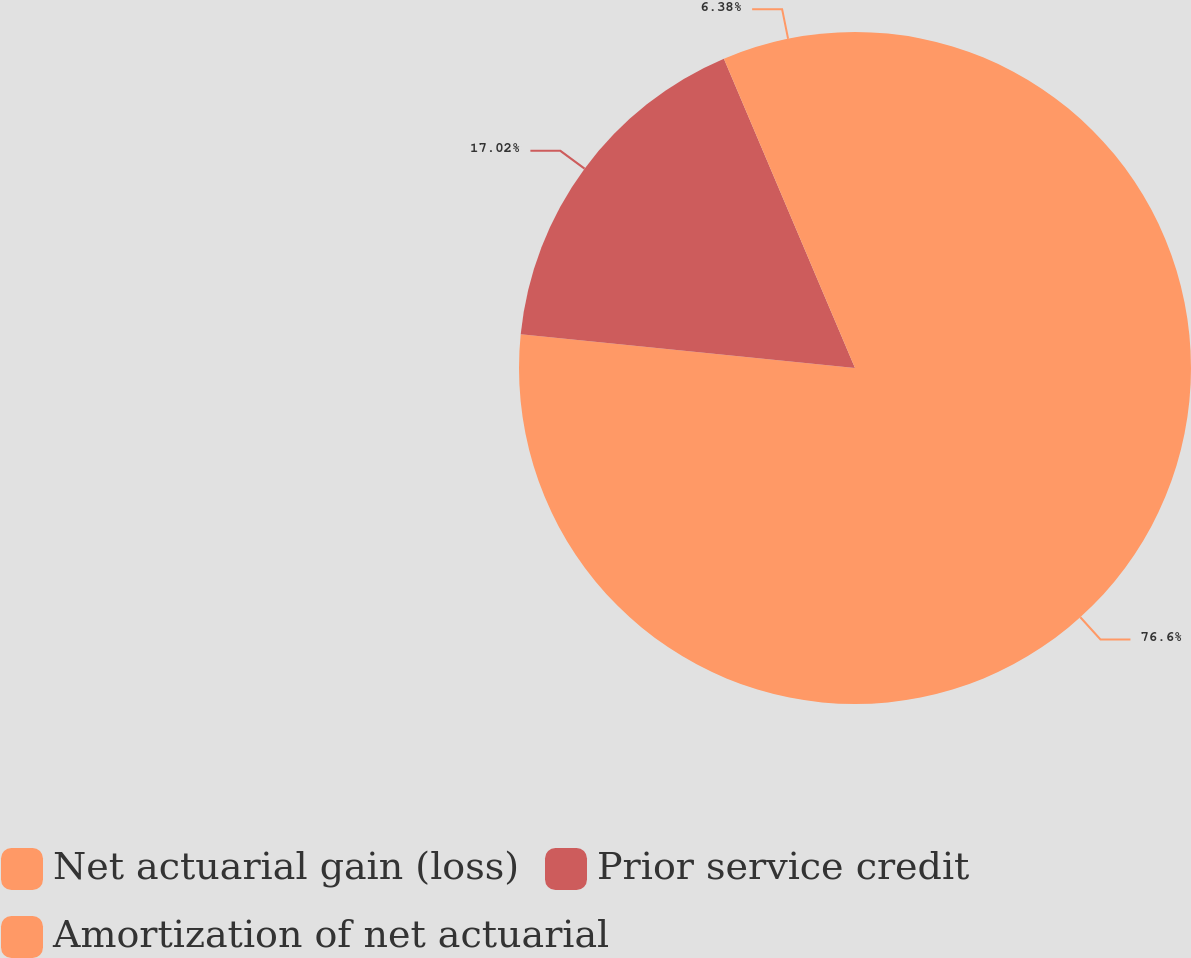<chart> <loc_0><loc_0><loc_500><loc_500><pie_chart><fcel>Net actuarial gain (loss)<fcel>Prior service credit<fcel>Amortization of net actuarial<nl><fcel>76.6%<fcel>17.02%<fcel>6.38%<nl></chart> 